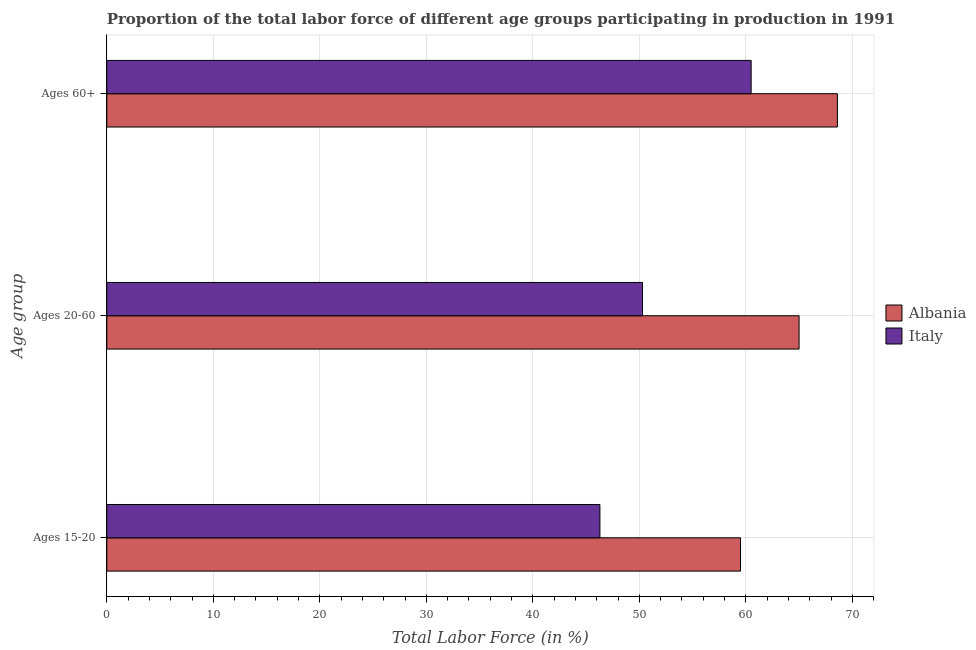How many groups of bars are there?
Your answer should be very brief. 3. Are the number of bars on each tick of the Y-axis equal?
Your answer should be very brief. Yes. What is the label of the 2nd group of bars from the top?
Offer a terse response. Ages 20-60. Across all countries, what is the maximum percentage of labor force within the age group 15-20?
Offer a very short reply. 59.5. Across all countries, what is the minimum percentage of labor force within the age group 20-60?
Provide a short and direct response. 50.3. In which country was the percentage of labor force above age 60 maximum?
Ensure brevity in your answer.  Albania. What is the total percentage of labor force within the age group 20-60 in the graph?
Your answer should be compact. 115.3. What is the difference between the percentage of labor force within the age group 20-60 in Albania and that in Italy?
Your answer should be compact. 14.7. What is the average percentage of labor force above age 60 per country?
Your response must be concise. 64.55. What is the difference between the percentage of labor force within the age group 15-20 and percentage of labor force within the age group 20-60 in Italy?
Keep it short and to the point. -4. What is the ratio of the percentage of labor force above age 60 in Albania to that in Italy?
Provide a succinct answer. 1.13. Is the difference between the percentage of labor force within the age group 15-20 in Albania and Italy greater than the difference between the percentage of labor force within the age group 20-60 in Albania and Italy?
Offer a terse response. No. What is the difference between the highest and the second highest percentage of labor force within the age group 15-20?
Give a very brief answer. 13.2. What is the difference between the highest and the lowest percentage of labor force above age 60?
Your answer should be compact. 8.1. In how many countries, is the percentage of labor force above age 60 greater than the average percentage of labor force above age 60 taken over all countries?
Your answer should be very brief. 1. Is the sum of the percentage of labor force within the age group 15-20 in Italy and Albania greater than the maximum percentage of labor force within the age group 20-60 across all countries?
Offer a terse response. Yes. What does the 2nd bar from the bottom in Ages 20-60 represents?
Keep it short and to the point. Italy. What is the difference between two consecutive major ticks on the X-axis?
Offer a very short reply. 10. Are the values on the major ticks of X-axis written in scientific E-notation?
Offer a terse response. No. Does the graph contain grids?
Ensure brevity in your answer.  Yes. How are the legend labels stacked?
Your response must be concise. Vertical. What is the title of the graph?
Make the answer very short. Proportion of the total labor force of different age groups participating in production in 1991. What is the label or title of the Y-axis?
Your answer should be compact. Age group. What is the Total Labor Force (in %) of Albania in Ages 15-20?
Make the answer very short. 59.5. What is the Total Labor Force (in %) of Italy in Ages 15-20?
Provide a succinct answer. 46.3. What is the Total Labor Force (in %) in Albania in Ages 20-60?
Your answer should be compact. 65. What is the Total Labor Force (in %) in Italy in Ages 20-60?
Offer a very short reply. 50.3. What is the Total Labor Force (in %) of Albania in Ages 60+?
Give a very brief answer. 68.6. What is the Total Labor Force (in %) of Italy in Ages 60+?
Make the answer very short. 60.5. Across all Age group, what is the maximum Total Labor Force (in %) of Albania?
Your answer should be very brief. 68.6. Across all Age group, what is the maximum Total Labor Force (in %) in Italy?
Provide a succinct answer. 60.5. Across all Age group, what is the minimum Total Labor Force (in %) in Albania?
Keep it short and to the point. 59.5. Across all Age group, what is the minimum Total Labor Force (in %) in Italy?
Your answer should be very brief. 46.3. What is the total Total Labor Force (in %) in Albania in the graph?
Provide a short and direct response. 193.1. What is the total Total Labor Force (in %) in Italy in the graph?
Keep it short and to the point. 157.1. What is the difference between the Total Labor Force (in %) in Italy in Ages 20-60 and that in Ages 60+?
Offer a terse response. -10.2. What is the difference between the Total Labor Force (in %) in Albania in Ages 15-20 and the Total Labor Force (in %) in Italy in Ages 20-60?
Ensure brevity in your answer.  9.2. What is the difference between the Total Labor Force (in %) in Albania in Ages 15-20 and the Total Labor Force (in %) in Italy in Ages 60+?
Offer a very short reply. -1. What is the average Total Labor Force (in %) of Albania per Age group?
Your answer should be very brief. 64.37. What is the average Total Labor Force (in %) in Italy per Age group?
Offer a terse response. 52.37. What is the difference between the Total Labor Force (in %) of Albania and Total Labor Force (in %) of Italy in Ages 60+?
Your response must be concise. 8.1. What is the ratio of the Total Labor Force (in %) of Albania in Ages 15-20 to that in Ages 20-60?
Your answer should be very brief. 0.92. What is the ratio of the Total Labor Force (in %) in Italy in Ages 15-20 to that in Ages 20-60?
Your response must be concise. 0.92. What is the ratio of the Total Labor Force (in %) of Albania in Ages 15-20 to that in Ages 60+?
Provide a succinct answer. 0.87. What is the ratio of the Total Labor Force (in %) of Italy in Ages 15-20 to that in Ages 60+?
Offer a terse response. 0.77. What is the ratio of the Total Labor Force (in %) of Albania in Ages 20-60 to that in Ages 60+?
Make the answer very short. 0.95. What is the ratio of the Total Labor Force (in %) in Italy in Ages 20-60 to that in Ages 60+?
Ensure brevity in your answer.  0.83. What is the difference between the highest and the second highest Total Labor Force (in %) in Albania?
Offer a terse response. 3.6. What is the difference between the highest and the lowest Total Labor Force (in %) in Italy?
Provide a succinct answer. 14.2. 